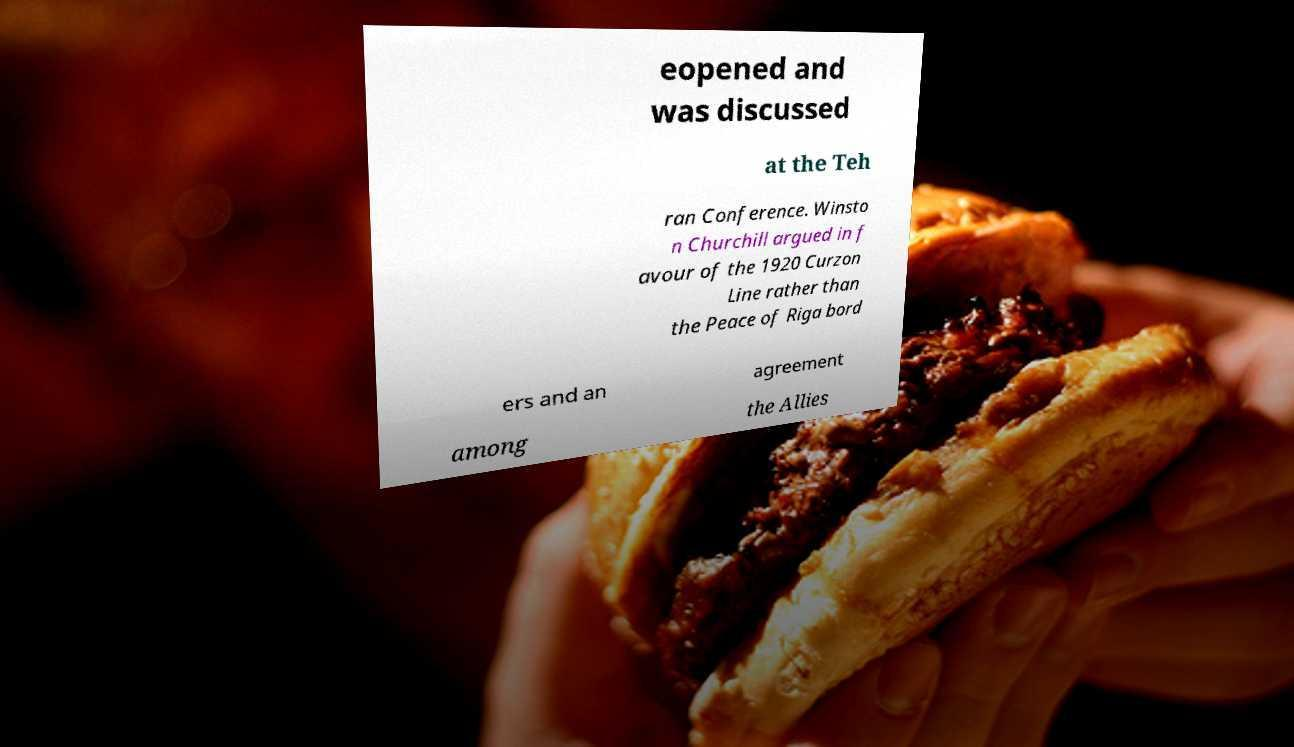Can you read and provide the text displayed in the image?This photo seems to have some interesting text. Can you extract and type it out for me? eopened and was discussed at the Teh ran Conference. Winsto n Churchill argued in f avour of the 1920 Curzon Line rather than the Peace of Riga bord ers and an agreement among the Allies 